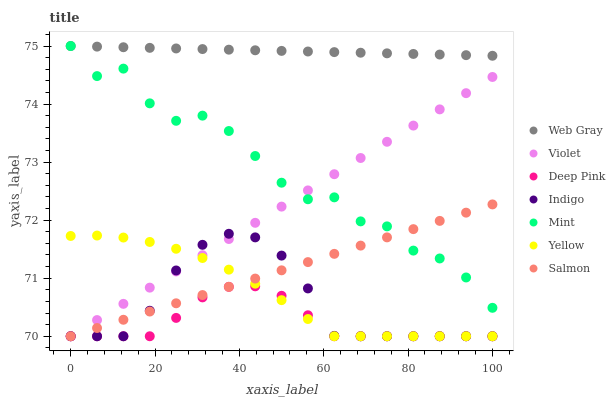Does Deep Pink have the minimum area under the curve?
Answer yes or no. Yes. Does Web Gray have the maximum area under the curve?
Answer yes or no. Yes. Does Indigo have the minimum area under the curve?
Answer yes or no. No. Does Indigo have the maximum area under the curve?
Answer yes or no. No. Is Web Gray the smoothest?
Answer yes or no. Yes. Is Mint the roughest?
Answer yes or no. Yes. Is Indigo the smoothest?
Answer yes or no. No. Is Indigo the roughest?
Answer yes or no. No. Does Indigo have the lowest value?
Answer yes or no. Yes. Does Mint have the lowest value?
Answer yes or no. No. Does Mint have the highest value?
Answer yes or no. Yes. Does Indigo have the highest value?
Answer yes or no. No. Is Deep Pink less than Web Gray?
Answer yes or no. Yes. Is Web Gray greater than Indigo?
Answer yes or no. Yes. Does Salmon intersect Deep Pink?
Answer yes or no. Yes. Is Salmon less than Deep Pink?
Answer yes or no. No. Is Salmon greater than Deep Pink?
Answer yes or no. No. Does Deep Pink intersect Web Gray?
Answer yes or no. No. 